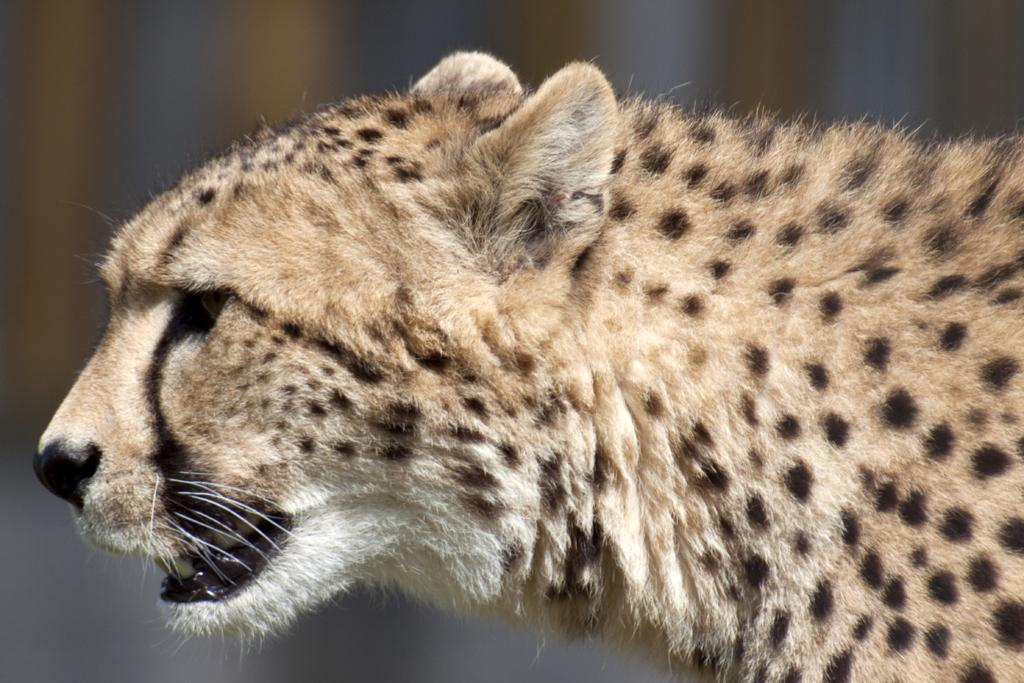What is the main subject of the picture? The main subject of the picture is a cheetah. Can you describe the background of the picture? The background portion of the picture is blurred. What is the value of the cheetah's daughter in the image? There is no mention of a cheetah's daughter or any value associated with the cheetah in the image. 